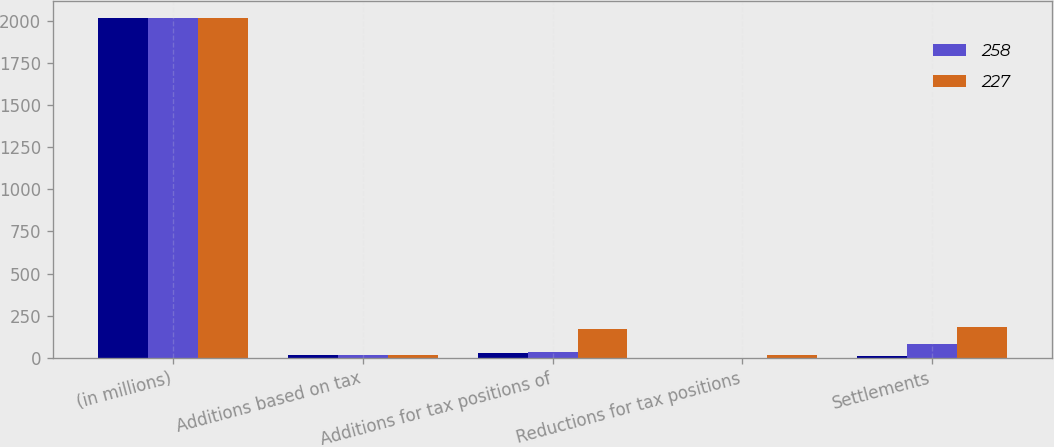Convert chart. <chart><loc_0><loc_0><loc_500><loc_500><stacked_bar_chart><ecel><fcel>(in millions)<fcel>Additions based on tax<fcel>Additions for tax positions of<fcel>Reductions for tax positions<fcel>Settlements<nl><fcel>nan<fcel>2014<fcel>15<fcel>29<fcel>2<fcel>11<nl><fcel>258<fcel>2013<fcel>15<fcel>35<fcel>1<fcel>84<nl><fcel>227<fcel>2012<fcel>15<fcel>170<fcel>16<fcel>186<nl></chart> 